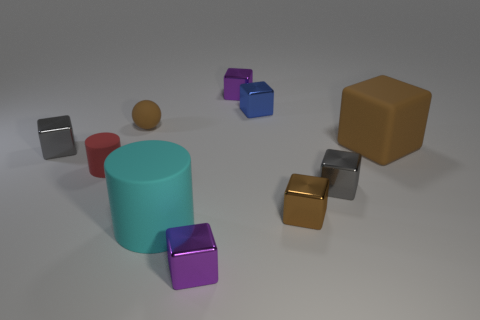There is a rubber object that is on the right side of the small purple cube in front of the small blue thing; are there any brown things that are to the right of it?
Make the answer very short. No. Does the blue thing have the same shape as the red thing?
Make the answer very short. No. Are there fewer small red things that are right of the big brown cube than big gray metal balls?
Your answer should be very brief. No. The small rubber thing that is in front of the small shiny thing left of the rubber cylinder on the right side of the small brown matte sphere is what color?
Your response must be concise. Red. How many rubber things are either big brown objects or red spheres?
Provide a short and direct response. 1. Is the size of the brown rubber sphere the same as the cyan rubber cylinder?
Make the answer very short. No. Is the number of small objects that are in front of the ball less than the number of small brown metal things that are behind the small blue shiny cube?
Offer a terse response. No. Is there anything else that has the same size as the brown sphere?
Give a very brief answer. Yes. How big is the red matte cylinder?
Offer a very short reply. Small. How many small things are either rubber things or gray shiny things?
Provide a succinct answer. 4. 